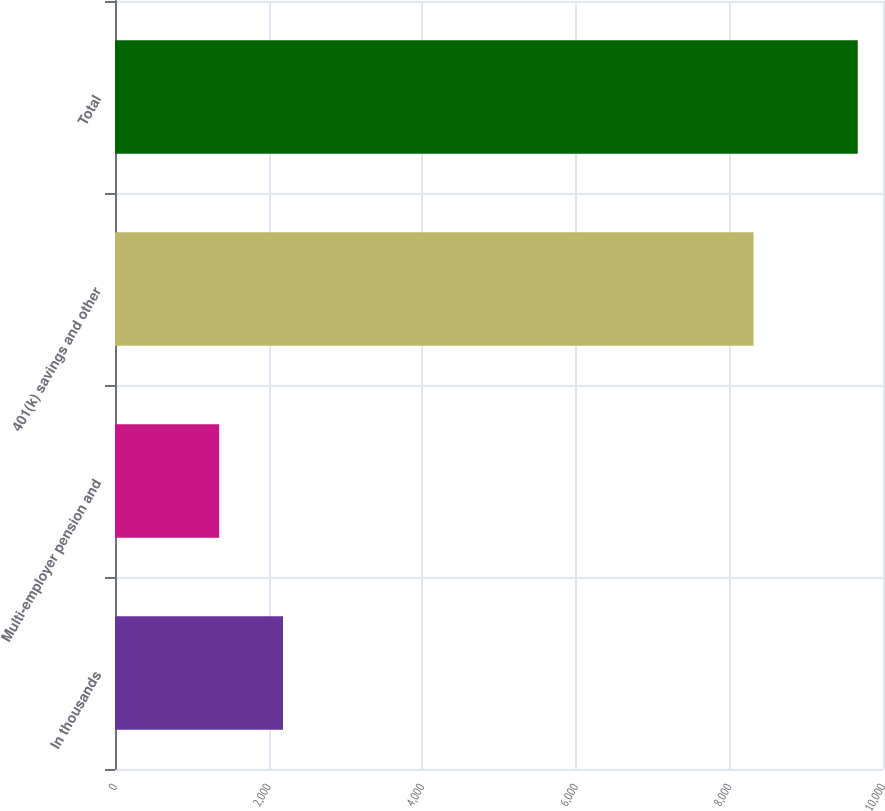Convert chart to OTSL. <chart><loc_0><loc_0><loc_500><loc_500><bar_chart><fcel>In thousands<fcel>Multi-employer pension and<fcel>401(k) savings and other<fcel>Total<nl><fcel>2187.5<fcel>1356<fcel>8315<fcel>9671<nl></chart> 